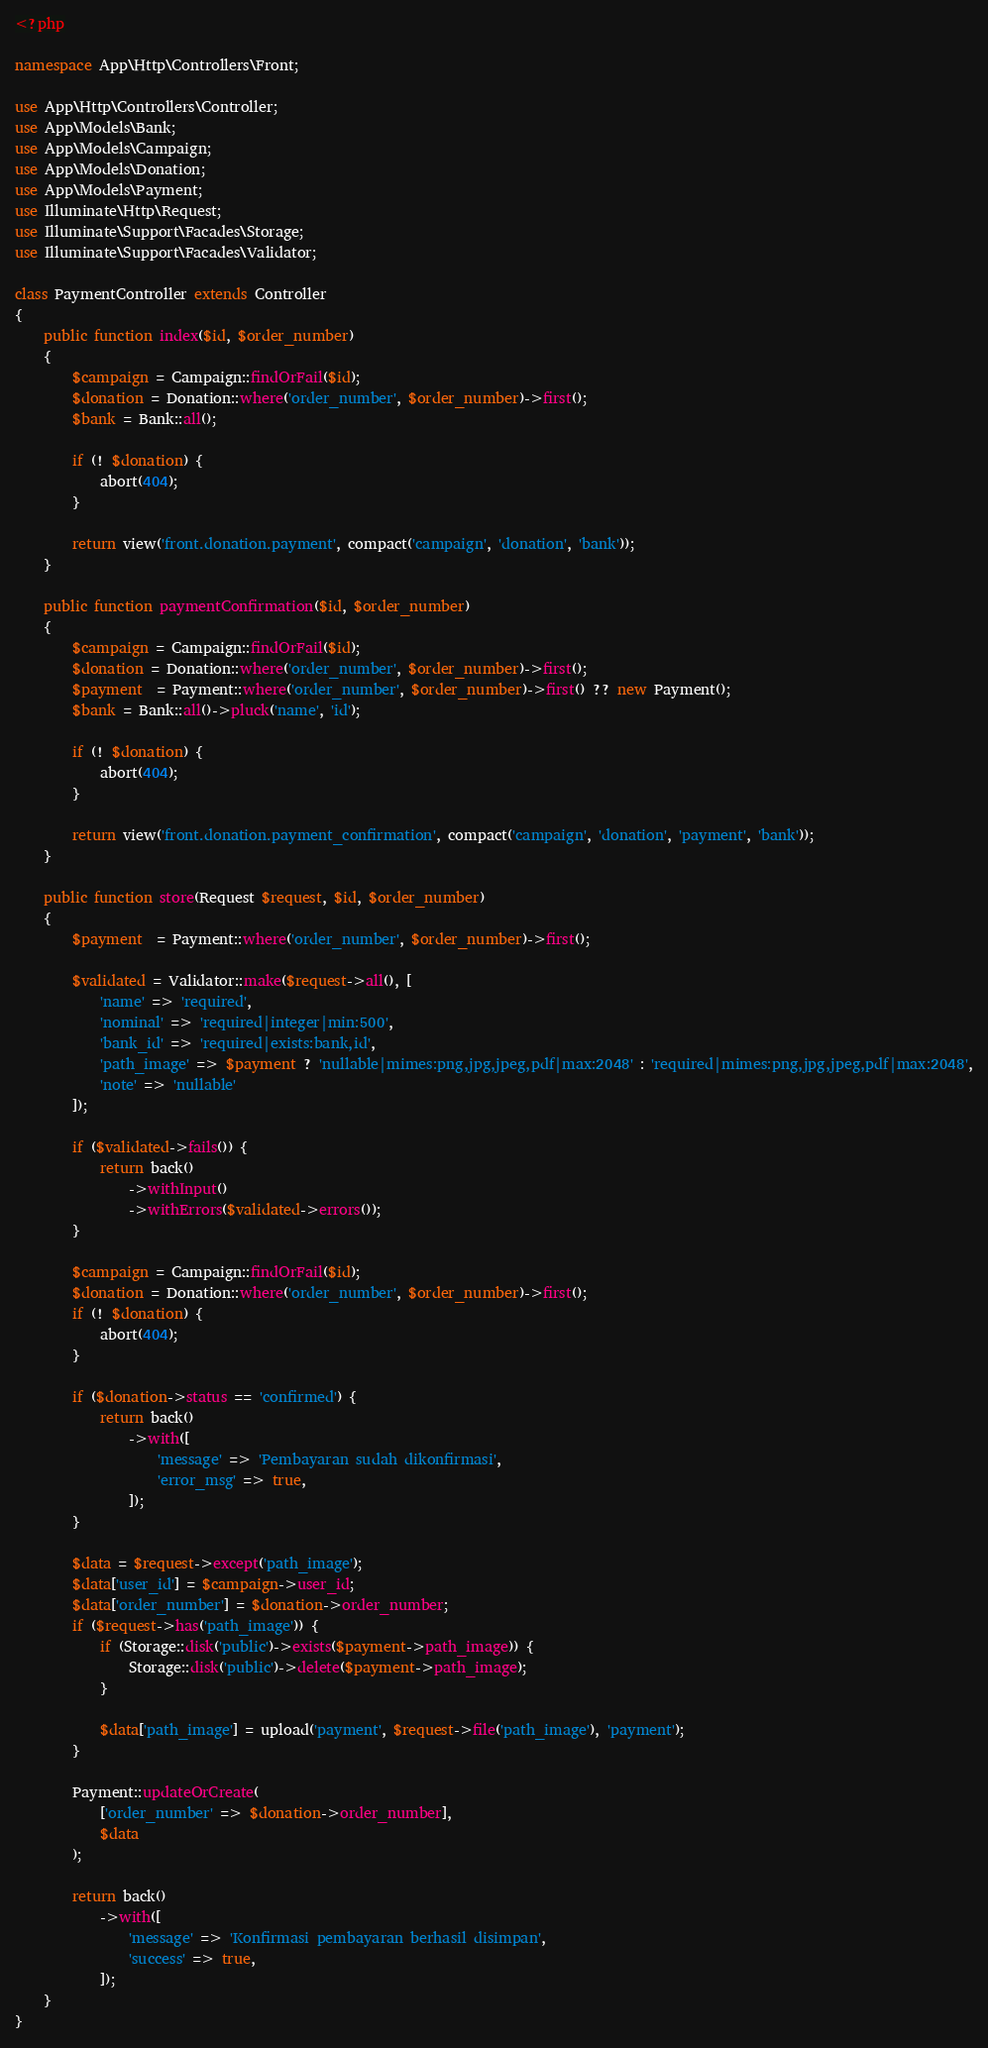Convert code to text. <code><loc_0><loc_0><loc_500><loc_500><_PHP_><?php

namespace App\Http\Controllers\Front;

use App\Http\Controllers\Controller;
use App\Models\Bank;
use App\Models\Campaign;
use App\Models\Donation;
use App\Models\Payment;
use Illuminate\Http\Request;
use Illuminate\Support\Facades\Storage;
use Illuminate\Support\Facades\Validator;

class PaymentController extends Controller
{
    public function index($id, $order_number)
    {
        $campaign = Campaign::findOrFail($id);
        $donation = Donation::where('order_number', $order_number)->first();
        $bank = Bank::all();
        
        if (! $donation) {
            abort(404);
        }

        return view('front.donation.payment', compact('campaign', 'donation', 'bank'));
    }

    public function paymentConfirmation($id, $order_number)
    {
        $campaign = Campaign::findOrFail($id);
        $donation = Donation::where('order_number', $order_number)->first();
        $payment  = Payment::where('order_number', $order_number)->first() ?? new Payment();
        $bank = Bank::all()->pluck('name', 'id');
        
        if (! $donation) {
            abort(404);
        }

        return view('front.donation.payment_confirmation', compact('campaign', 'donation', 'payment', 'bank'));
    }

    public function store(Request $request, $id, $order_number)
    {
        $payment  = Payment::where('order_number', $order_number)->first();

        $validated = Validator::make($request->all(), [
            'name' => 'required',
            'nominal' => 'required|integer|min:500',
            'bank_id' => 'required|exists:bank,id',
            'path_image' => $payment ? 'nullable|mimes:png,jpg,jpeg,pdf|max:2048' : 'required|mimes:png,jpg,jpeg,pdf|max:2048',
            'note' => 'nullable'
        ]);

        if ($validated->fails()) {
            return back()
                ->withInput()
                ->withErrors($validated->errors());
        }

        $campaign = Campaign::findOrFail($id);
        $donation = Donation::where('order_number', $order_number)->first();
        if (! $donation) {
            abort(404);
        }

        if ($donation->status == 'confirmed') {
            return back()
                ->with([
                    'message' => 'Pembayaran sudah dikonfirmasi',
                    'error_msg' => true,
                ]);
        }

        $data = $request->except('path_image');
        $data['user_id'] = $campaign->user_id;
        $data['order_number'] = $donation->order_number;
        if ($request->has('path_image')) {
            if (Storage::disk('public')->exists($payment->path_image)) {
                Storage::disk('public')->delete($payment->path_image);
            }

            $data['path_image'] = upload('payment', $request->file('path_image'), 'payment');
        }

        Payment::updateOrCreate(
            ['order_number' => $donation->order_number],
            $data
        );

        return back()
            ->with([
                'message' => 'Konfirmasi pembayaran berhasil disimpan',
                'success' => true,
            ]);
    }
}
</code> 